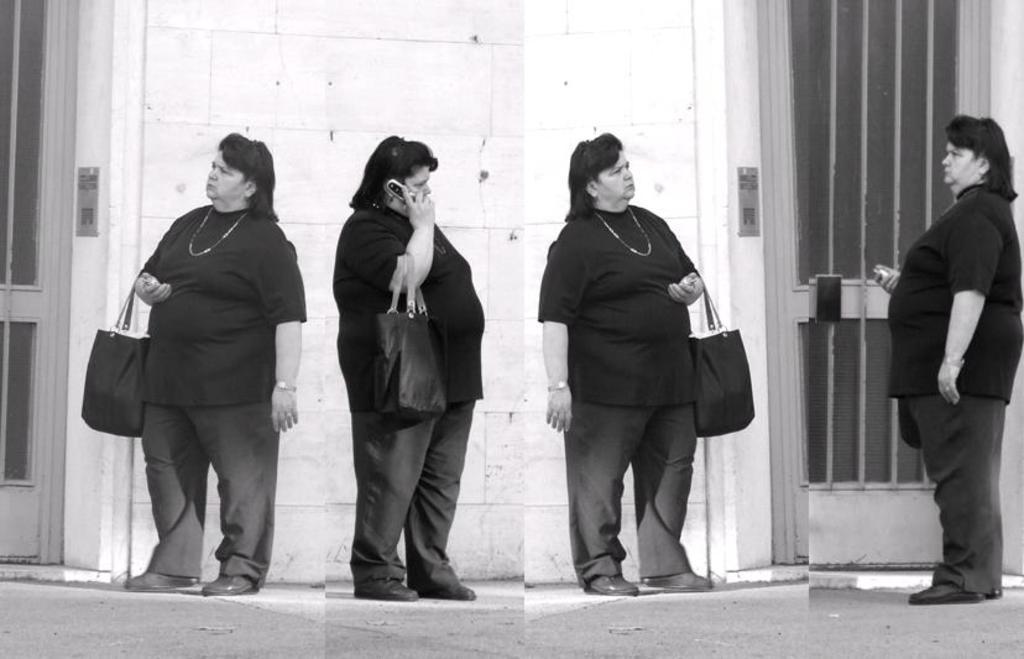Describe this image in one or two sentences. This image contains a collage of photos of a woman. The woman is standing on the land. She is carrying a bag. Behind her there is a wall having a door. She is holding a mobile phone. Right side there is a fence. 